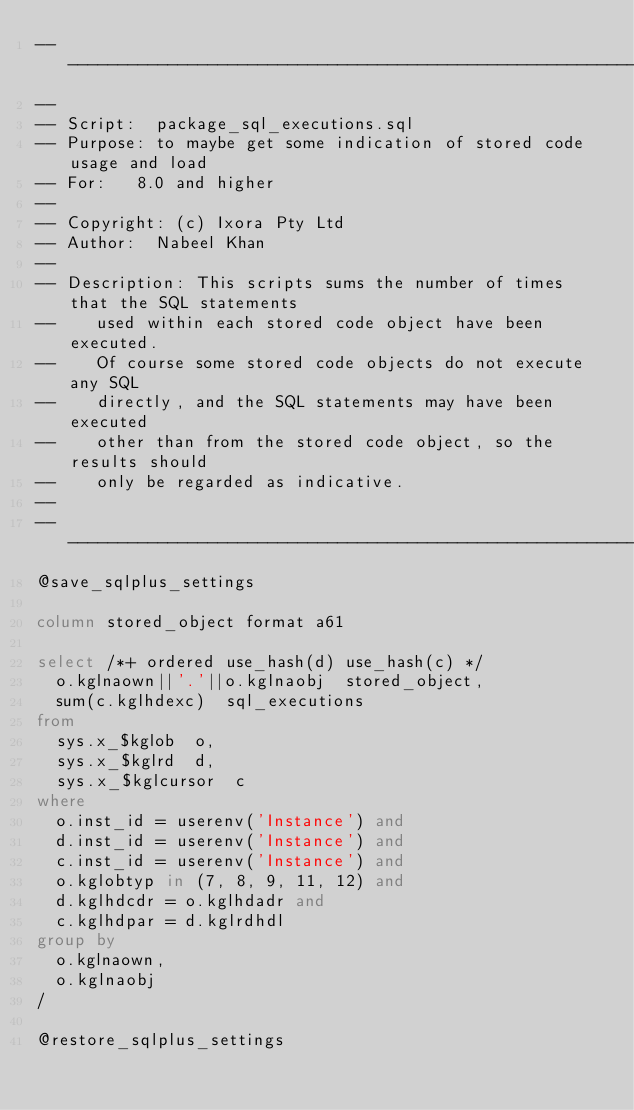Convert code to text. <code><loc_0><loc_0><loc_500><loc_500><_SQL_>-------------------------------------------------------------------------------
--
-- Script:	package_sql_executions.sql
-- Purpose:	to maybe get some indication of stored code usage and load 
-- For:		8.0 and higher
--
-- Copyright:	(c) Ixora Pty Ltd
-- Author:	Nabeel Khan
--
-- Description:	This scripts sums the number of times that the SQL statements
--		used within each stored code object have been executed.
--		Of course some stored code objects do not execute any SQL 
--		directly, and the SQL statements may have been executed
--		other than from the stored code object, so the results should
--		only be regarded as indicative.
--
-------------------------------------------------------------------------------
@save_sqlplus_settings

column stored_object format a61

select /*+ ordered use_hash(d) use_hash(c) */
  o.kglnaown||'.'||o.kglnaobj  stored_object,
  sum(c.kglhdexc)  sql_executions
from
  sys.x_$kglob  o,
  sys.x_$kglrd  d,
  sys.x_$kglcursor  c
where
  o.inst_id = userenv('Instance') and
  d.inst_id = userenv('Instance') and
  c.inst_id = userenv('Instance') and
  o.kglobtyp in (7, 8, 9, 11, 12) and
  d.kglhdcdr = o.kglhdadr and
  c.kglhdpar = d.kglrdhdl
group by
  o.kglnaown,
  o.kglnaobj
/

@restore_sqlplus_settings
</code> 